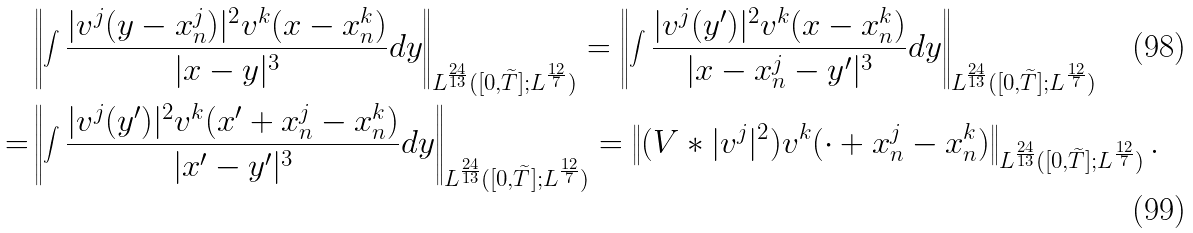<formula> <loc_0><loc_0><loc_500><loc_500>& \left \| \int \frac { | v ^ { j } ( y - x _ { n } ^ { j } ) | ^ { 2 } v ^ { k } ( x - x _ { n } ^ { k } ) } { | x - y | ^ { 3 } } d y \right \| _ { L ^ { \frac { 2 4 } { 1 3 } } ( [ 0 , \widetilde { T } ] ; L ^ { \frac { 1 2 } { 7 } } ) } = \left \| \int \frac { | v ^ { j } ( y ^ { \prime } ) | ^ { 2 } v ^ { k } ( x - x _ { n } ^ { k } ) } { | x - x _ { n } ^ { j } - y ^ { \prime } | ^ { 3 } } d y \right \| _ { L ^ { \frac { 2 4 } { 1 3 } } ( [ 0 , \widetilde { T } ] ; L ^ { \frac { 1 2 } { 7 } } ) } \\ = & \left \| \int \frac { | v ^ { j } ( y ^ { \prime } ) | ^ { 2 } v ^ { k } ( x ^ { \prime } + x _ { n } ^ { j } - x _ { n } ^ { k } ) } { | x ^ { \prime } - y ^ { \prime } | ^ { 3 } } d y \right \| _ { L ^ { \frac { 2 4 } { 1 3 } } ( [ 0 , \widetilde { T } ] ; L ^ { \frac { 1 2 } { 7 } } ) } = \left \| ( V \ast | v ^ { j } | ^ { 2 } ) v ^ { k } ( \cdot + x _ { n } ^ { j } - x _ { n } ^ { k } ) \right \| _ { L ^ { \frac { 2 4 } { 1 3 } } ( [ 0 , \widetilde { T } ] ; L ^ { \frac { 1 2 } { 7 } } ) } .</formula> 